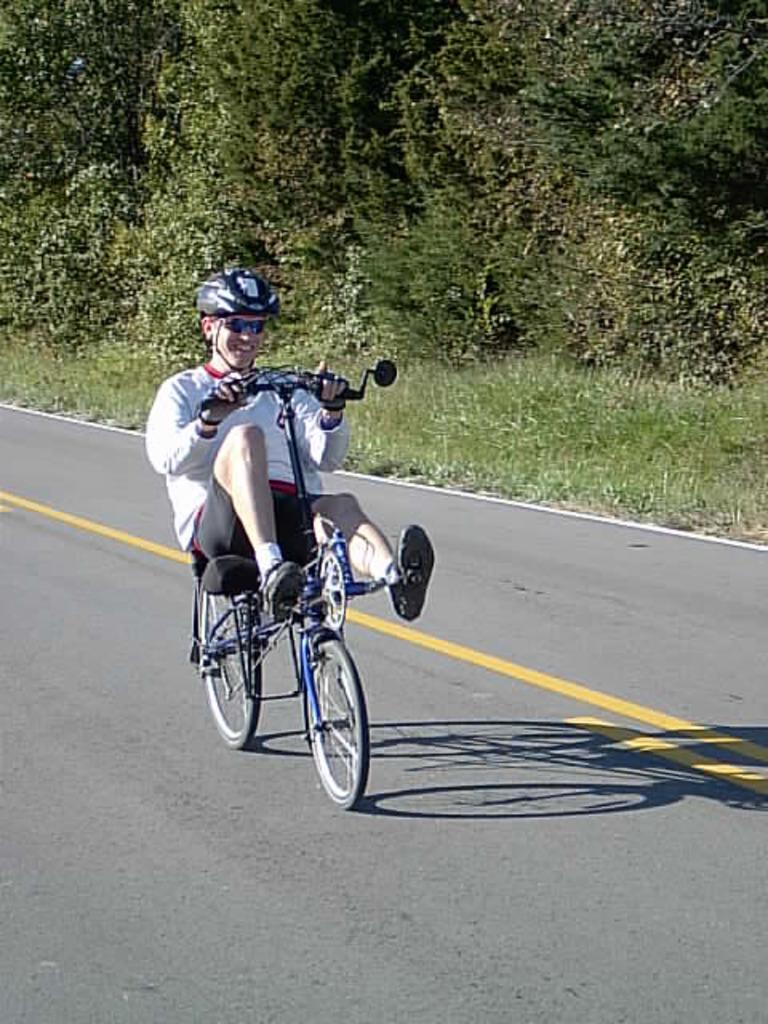What is the man in the image doing? The man is riding a bicycle in the image. What safety precaution is the man taking while riding the bicycle? The man is wearing a helmet. What type of natural environment can be seen in the image? There are trees and grass visible in the image. What type of news is the man reading while riding the bicycle? A: There is no news visible in the image, and the man is not shown reading anything. How many bears are visible in the image? There are no bears present in the image. 